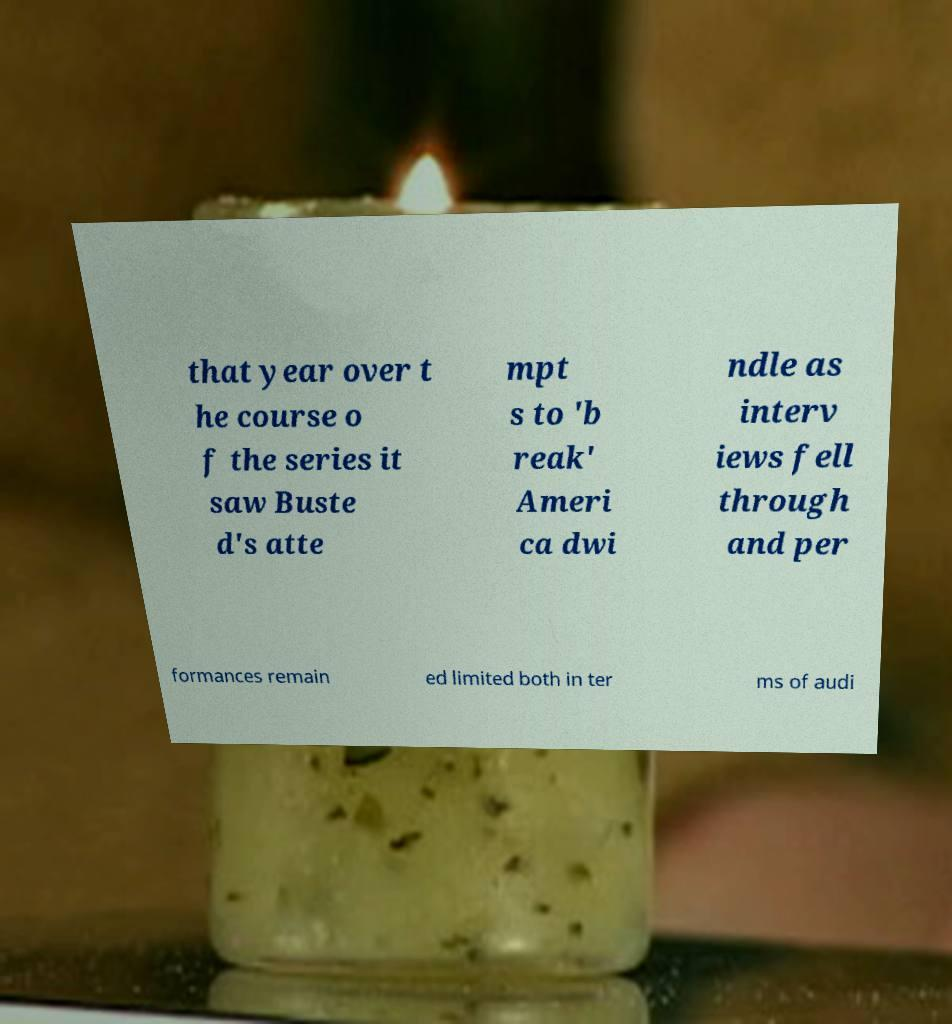Could you extract and type out the text from this image? that year over t he course o f the series it saw Buste d's atte mpt s to 'b reak' Ameri ca dwi ndle as interv iews fell through and per formances remain ed limited both in ter ms of audi 